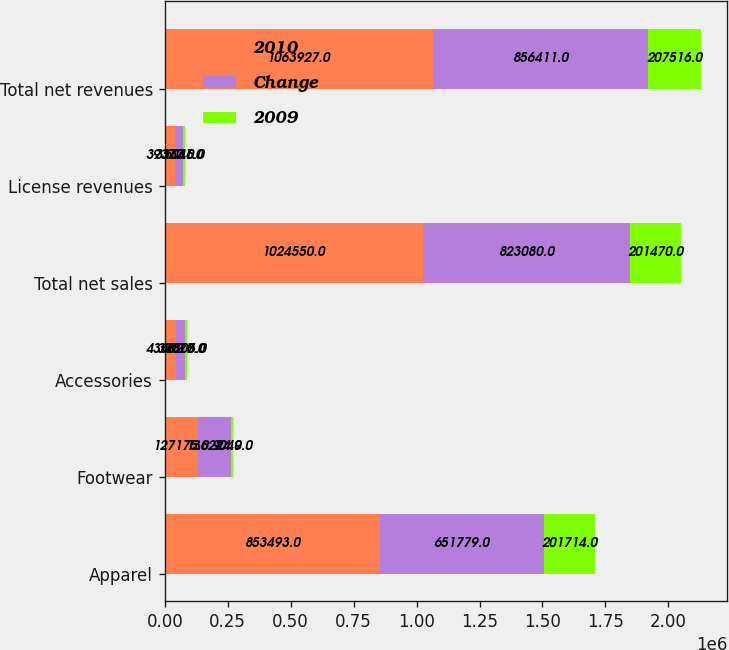<chart> <loc_0><loc_0><loc_500><loc_500><stacked_bar_chart><ecel><fcel>Apparel<fcel>Footwear<fcel>Accessories<fcel>Total net sales<fcel>License revenues<fcel>Total net revenues<nl><fcel>2010<fcel>853493<fcel>127175<fcel>43882<fcel>1.02455e+06<fcel>39377<fcel>1.06393e+06<nl><fcel>Change<fcel>651779<fcel>136224<fcel>35077<fcel>823080<fcel>33331<fcel>856411<nl><fcel>2009<fcel>201714<fcel>9049<fcel>8805<fcel>201470<fcel>6046<fcel>207516<nl></chart> 